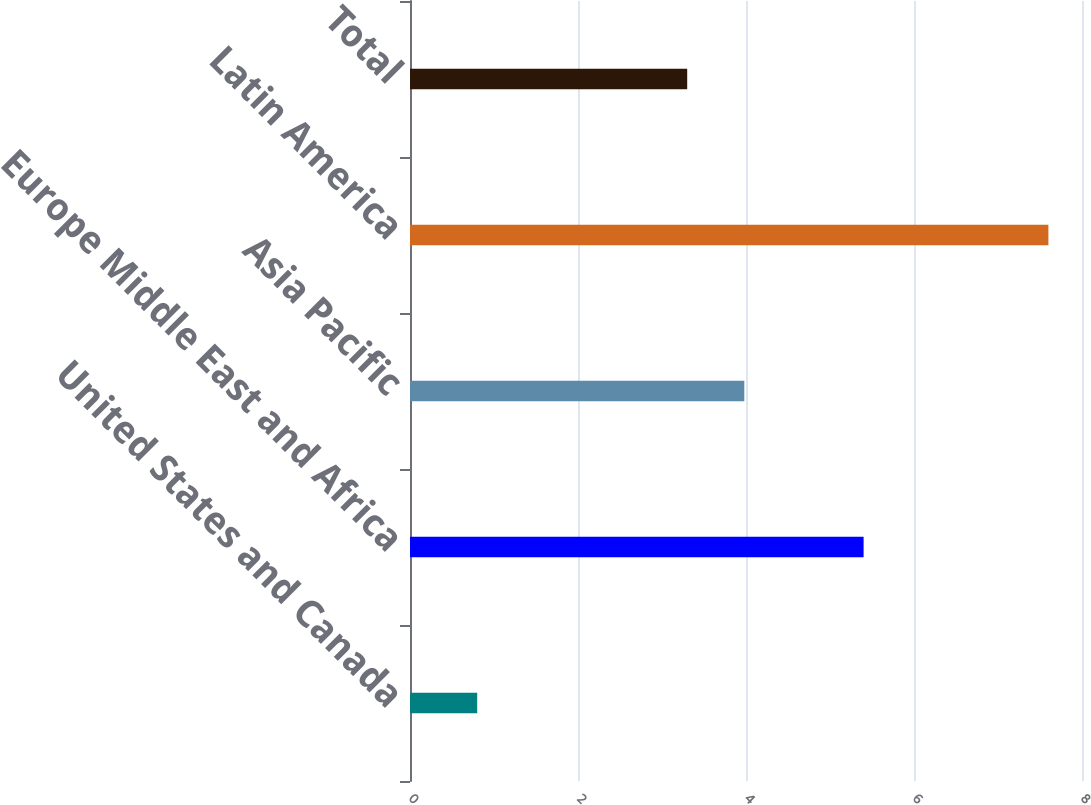<chart> <loc_0><loc_0><loc_500><loc_500><bar_chart><fcel>United States and Canada<fcel>Europe Middle East and Africa<fcel>Asia Pacific<fcel>Latin America<fcel>Total<nl><fcel>0.8<fcel>5.4<fcel>3.98<fcel>7.6<fcel>3.3<nl></chart> 